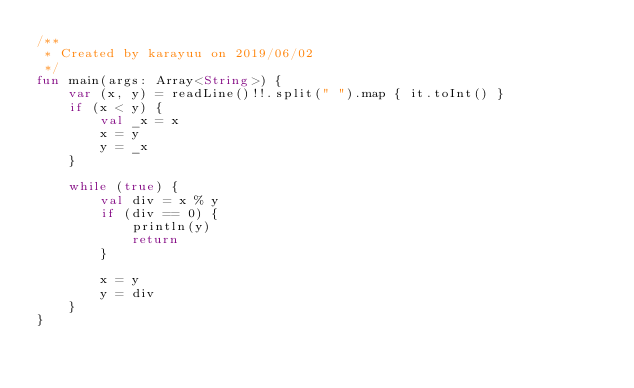<code> <loc_0><loc_0><loc_500><loc_500><_Kotlin_>/**
 * Created by karayuu on 2019/06/02
 */
fun main(args: Array<String>) {
    var (x, y) = readLine()!!.split(" ").map { it.toInt() }
    if (x < y) {
        val _x = x
        x = y
        y = _x
    }

    while (true) {
        val div = x % y
        if (div == 0) {
            println(y)
            return
        }

        x = y
        y = div
    }
}

</code> 